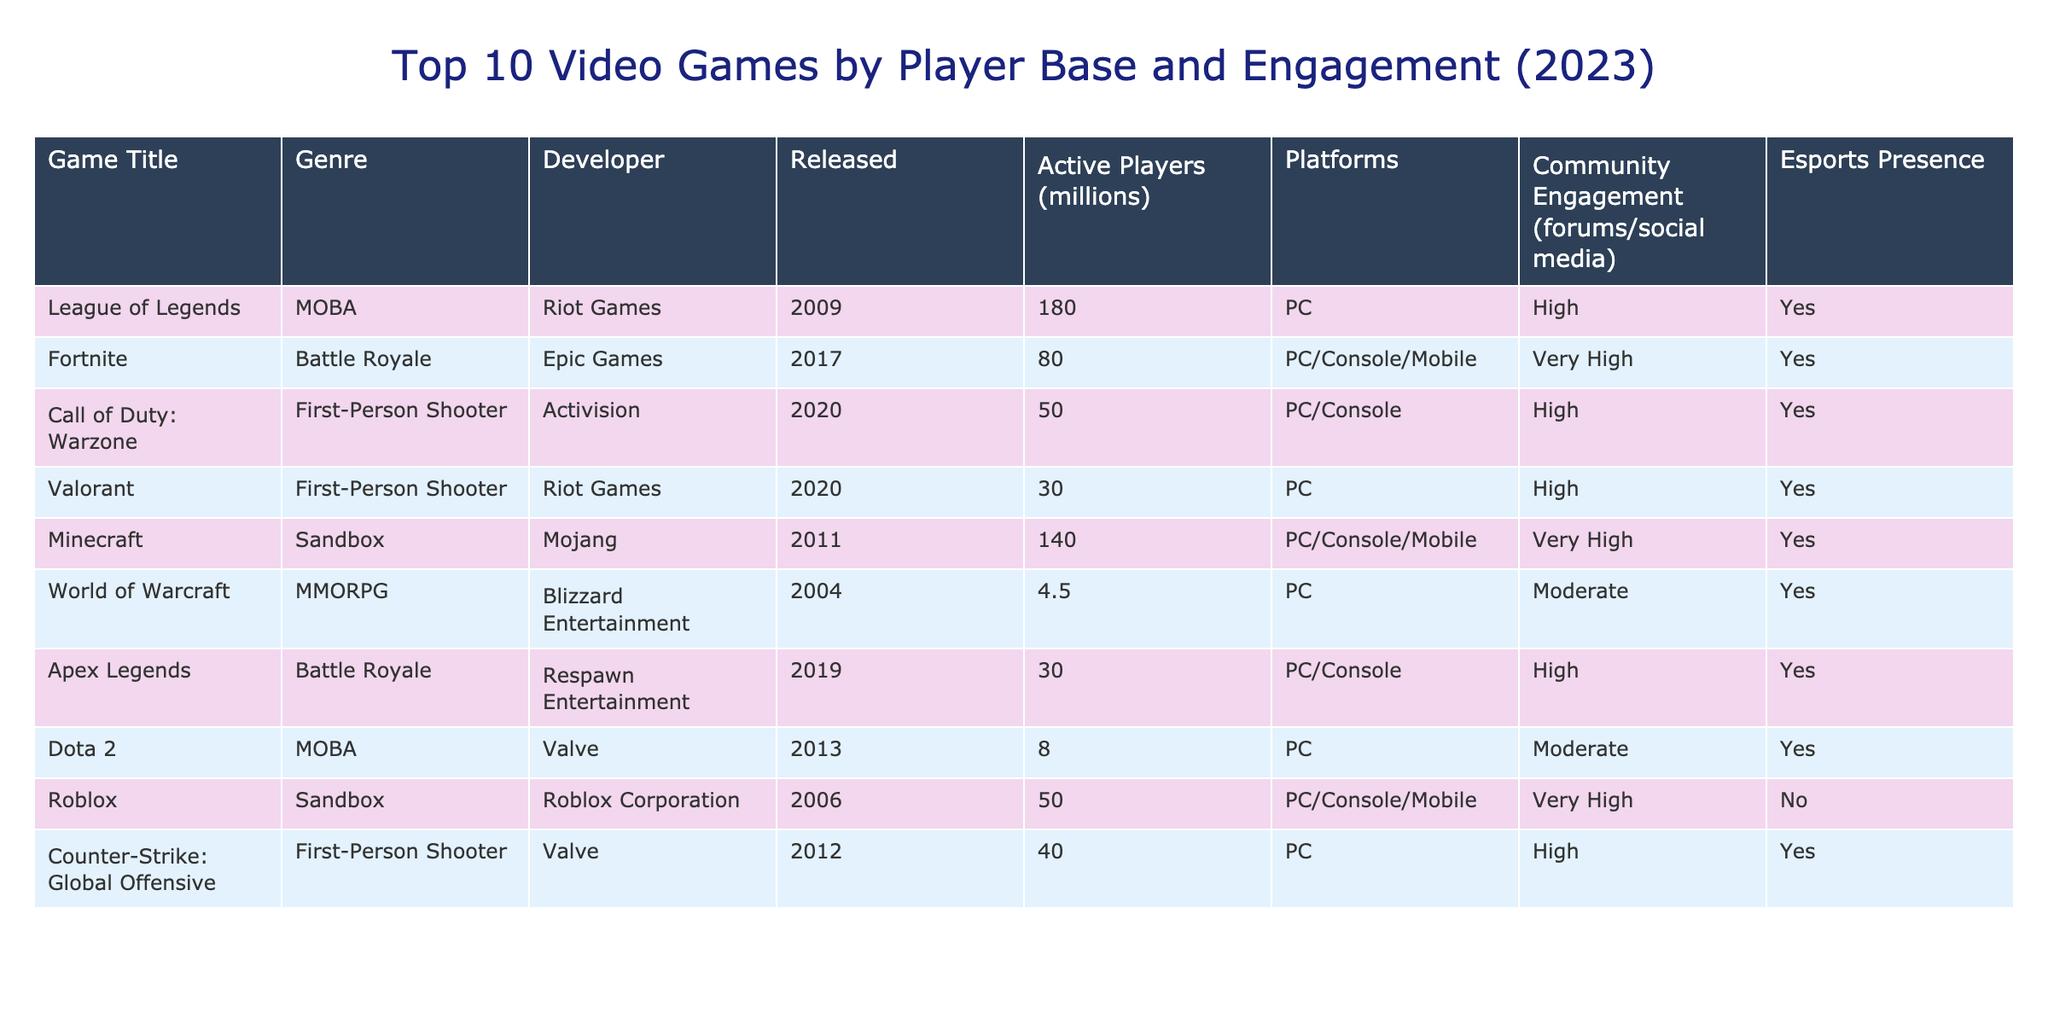What's the game with the highest number of active players? League of Legends has the highest number of active players at 180 million according to the table.
Answer: League of Legends Which game has a Very High community engagement but no esports presence? Roblox is the only game listed that has Very High community engagement but does not have esports presence indicated.
Answer: Roblox How many games were released after 2015? The games launched after 2015 are Fortnite (2017), Call of Duty: Warzone (2020), Valorant (2020), and Apex Legends (2019). That makes a total of 4 games released after 2015.
Answer: 4 What is the average number of active players for the games in this table? The total number of active players is 180 + 80 + 50 + 30 + 140 + 4.5 + 30 + 8 + 50 + 40 = 612.5 million, and there are 10 games. So, the average is 612.5 / 10 = 61.25 million.
Answer: 61.25 million Is World of Warcraft the only MMORPG listed in the table? Yes, World of Warcraft, which was released in 2004, is the only MMORPG in the table.
Answer: Yes What percentage of games in the table have a High or Very High community engagement? There are 8 games with High or Very High community engagement out of 10 total games. So, the percentage is (8/10) * 100 = 80%.
Answer: 80% What is the difference between the number of active players in Minecraft and Call of Duty: Warzone? Minecraft has 140 million active players and Call of Duty: Warzone has 50 million. The difference is 140 - 50 = 90 million.
Answer: 90 million Which genres have games with esports presence? The genres with esports presence indicated in the table are MOBA, Battle Royale, First-Person Shooter, and MMORPG.
Answer: MOBA, Battle Royale, First-Person Shooter, MMORPG How many games are available on multiple platforms? The games with multiple platforms are Fortnite, Minecraft, and Roblox. Therefore, there are 3 games available on multiple platforms.
Answer: 3 